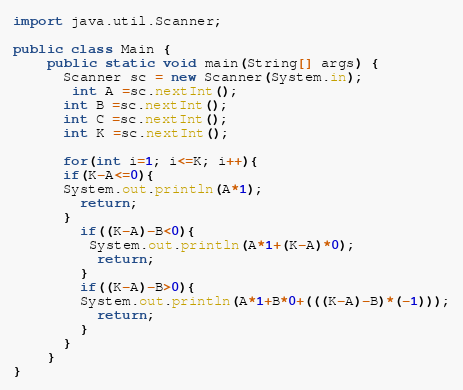<code> <loc_0><loc_0><loc_500><loc_500><_Java_>import java.util.Scanner;
 
public class Main {
	public static void main(String[] args) {
      Scanner sc = new Scanner(System.in);
       int A =sc.nextInt();
      int B =sc.nextInt();
      int C =sc.nextInt();
      int K =sc.nextInt();
      
      for(int i=1; i<=K; i++){
      if(K-A<=0){
      System.out.println(A*1);
        return;
      }
        if((K-A)-B<0){
         System.out.println(A*1+(K-A)*0);
          return;
        }
        if((K-A)-B>0){
        System.out.println(A*1+B*0+(((K-A)-B)*(-1)));
          return;
        }
      }
    }
}</code> 